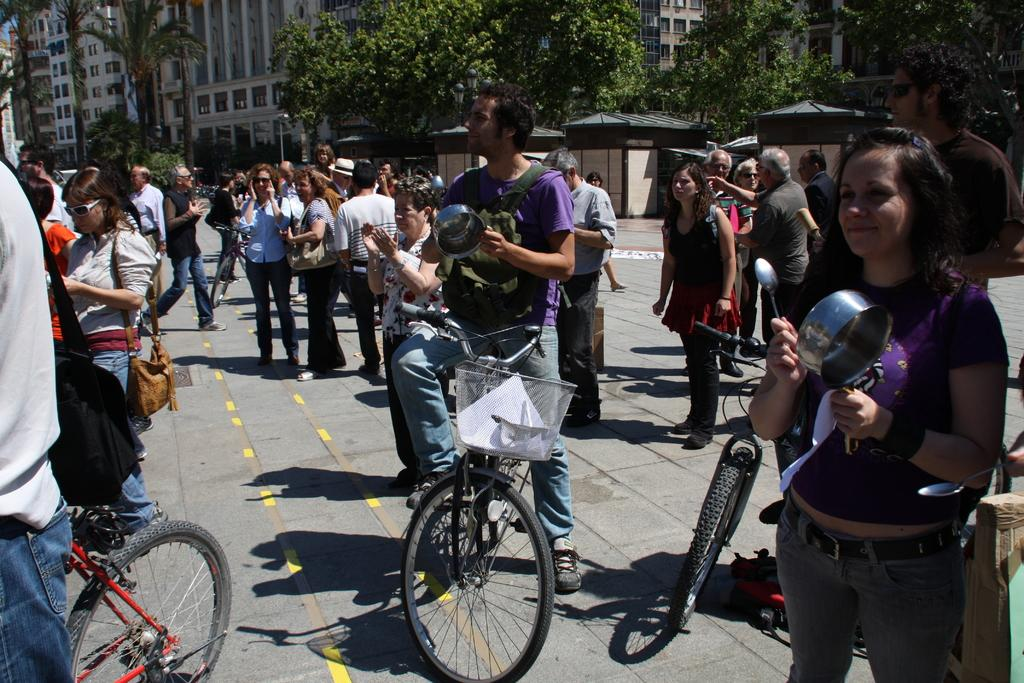What are the people in the image doing? There are people standing on the road and people sitting on bicycles in the image. Can you describe the positions of the people in the image? Some people are standing on the road, while others are sitting on bicycles. What type of suit is the bicycle wearing in the image? There are no bicycles wearing suits in the image, as bicycles are inanimate objects and cannot wear clothing. 